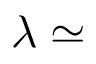Convert formula to latex. <formula><loc_0><loc_0><loc_500><loc_500>\lambda \simeq</formula> 